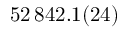Convert formula to latex. <formula><loc_0><loc_0><loc_500><loc_500>5 2 \, 8 4 2 . 1 ( 2 4 )</formula> 